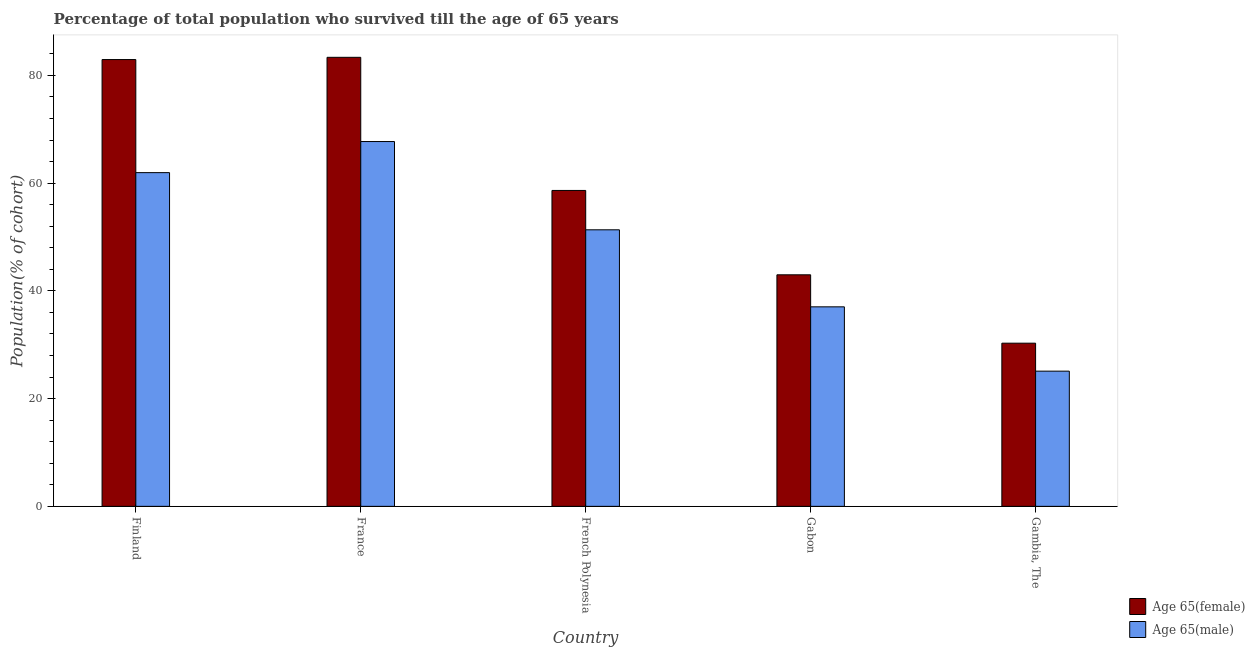How many different coloured bars are there?
Your answer should be very brief. 2. How many groups of bars are there?
Offer a terse response. 5. Are the number of bars per tick equal to the number of legend labels?
Your response must be concise. Yes. Are the number of bars on each tick of the X-axis equal?
Offer a terse response. Yes. How many bars are there on the 3rd tick from the left?
Your answer should be very brief. 2. What is the label of the 4th group of bars from the left?
Make the answer very short. Gabon. In how many cases, is the number of bars for a given country not equal to the number of legend labels?
Provide a succinct answer. 0. What is the percentage of female population who survived till age of 65 in Gabon?
Ensure brevity in your answer.  42.98. Across all countries, what is the maximum percentage of male population who survived till age of 65?
Offer a very short reply. 67.72. Across all countries, what is the minimum percentage of male population who survived till age of 65?
Provide a succinct answer. 25.1. In which country was the percentage of male population who survived till age of 65 maximum?
Offer a very short reply. France. In which country was the percentage of male population who survived till age of 65 minimum?
Provide a short and direct response. Gambia, The. What is the total percentage of male population who survived till age of 65 in the graph?
Your answer should be compact. 243.12. What is the difference between the percentage of male population who survived till age of 65 in Finland and that in France?
Provide a short and direct response. -5.77. What is the difference between the percentage of male population who survived till age of 65 in Gambia, The and the percentage of female population who survived till age of 65 in France?
Make the answer very short. -58.25. What is the average percentage of female population who survived till age of 65 per country?
Your answer should be compact. 59.64. What is the difference between the percentage of female population who survived till age of 65 and percentage of male population who survived till age of 65 in Gabon?
Offer a very short reply. 5.95. In how many countries, is the percentage of female population who survived till age of 65 greater than 52 %?
Make the answer very short. 3. What is the ratio of the percentage of female population who survived till age of 65 in Gabon to that in Gambia, The?
Your answer should be very brief. 1.42. Is the percentage of male population who survived till age of 65 in France less than that in Gambia, The?
Offer a very short reply. No. Is the difference between the percentage of female population who survived till age of 65 in French Polynesia and Gabon greater than the difference between the percentage of male population who survived till age of 65 in French Polynesia and Gabon?
Ensure brevity in your answer.  Yes. What is the difference between the highest and the second highest percentage of male population who survived till age of 65?
Provide a short and direct response. 5.77. What is the difference between the highest and the lowest percentage of female population who survived till age of 65?
Provide a short and direct response. 53.06. Is the sum of the percentage of male population who survived till age of 65 in French Polynesia and Gambia, The greater than the maximum percentage of female population who survived till age of 65 across all countries?
Give a very brief answer. No. What does the 1st bar from the left in Gambia, The represents?
Your answer should be compact. Age 65(female). What does the 2nd bar from the right in Gambia, The represents?
Provide a short and direct response. Age 65(female). Are all the bars in the graph horizontal?
Your response must be concise. No. How many countries are there in the graph?
Provide a succinct answer. 5. What is the difference between two consecutive major ticks on the Y-axis?
Provide a short and direct response. 20. Does the graph contain any zero values?
Offer a very short reply. No. Does the graph contain grids?
Offer a terse response. No. What is the title of the graph?
Offer a terse response. Percentage of total population who survived till the age of 65 years. What is the label or title of the Y-axis?
Ensure brevity in your answer.  Population(% of cohort). What is the Population(% of cohort) in Age 65(female) in Finland?
Keep it short and to the point. 82.93. What is the Population(% of cohort) in Age 65(male) in Finland?
Ensure brevity in your answer.  61.94. What is the Population(% of cohort) of Age 65(female) in France?
Your response must be concise. 83.35. What is the Population(% of cohort) of Age 65(male) in France?
Your answer should be compact. 67.72. What is the Population(% of cohort) in Age 65(female) in French Polynesia?
Make the answer very short. 58.64. What is the Population(% of cohort) of Age 65(male) in French Polynesia?
Keep it short and to the point. 51.33. What is the Population(% of cohort) of Age 65(female) in Gabon?
Your response must be concise. 42.98. What is the Population(% of cohort) in Age 65(male) in Gabon?
Your response must be concise. 37.03. What is the Population(% of cohort) in Age 65(female) in Gambia, The?
Your response must be concise. 30.29. What is the Population(% of cohort) in Age 65(male) in Gambia, The?
Offer a very short reply. 25.1. Across all countries, what is the maximum Population(% of cohort) of Age 65(female)?
Your answer should be very brief. 83.35. Across all countries, what is the maximum Population(% of cohort) in Age 65(male)?
Your response must be concise. 67.72. Across all countries, what is the minimum Population(% of cohort) in Age 65(female)?
Give a very brief answer. 30.29. Across all countries, what is the minimum Population(% of cohort) in Age 65(male)?
Offer a terse response. 25.1. What is the total Population(% of cohort) in Age 65(female) in the graph?
Give a very brief answer. 298.18. What is the total Population(% of cohort) in Age 65(male) in the graph?
Offer a very short reply. 243.12. What is the difference between the Population(% of cohort) in Age 65(female) in Finland and that in France?
Your answer should be compact. -0.41. What is the difference between the Population(% of cohort) of Age 65(male) in Finland and that in France?
Make the answer very short. -5.77. What is the difference between the Population(% of cohort) of Age 65(female) in Finland and that in French Polynesia?
Give a very brief answer. 24.3. What is the difference between the Population(% of cohort) in Age 65(male) in Finland and that in French Polynesia?
Offer a very short reply. 10.61. What is the difference between the Population(% of cohort) in Age 65(female) in Finland and that in Gabon?
Keep it short and to the point. 39.95. What is the difference between the Population(% of cohort) of Age 65(male) in Finland and that in Gabon?
Keep it short and to the point. 24.91. What is the difference between the Population(% of cohort) of Age 65(female) in Finland and that in Gambia, The?
Give a very brief answer. 52.65. What is the difference between the Population(% of cohort) in Age 65(male) in Finland and that in Gambia, The?
Offer a very short reply. 36.85. What is the difference between the Population(% of cohort) in Age 65(female) in France and that in French Polynesia?
Your response must be concise. 24.71. What is the difference between the Population(% of cohort) in Age 65(male) in France and that in French Polynesia?
Keep it short and to the point. 16.38. What is the difference between the Population(% of cohort) in Age 65(female) in France and that in Gabon?
Ensure brevity in your answer.  40.37. What is the difference between the Population(% of cohort) in Age 65(male) in France and that in Gabon?
Provide a short and direct response. 30.68. What is the difference between the Population(% of cohort) of Age 65(female) in France and that in Gambia, The?
Provide a short and direct response. 53.06. What is the difference between the Population(% of cohort) in Age 65(male) in France and that in Gambia, The?
Provide a succinct answer. 42.62. What is the difference between the Population(% of cohort) in Age 65(female) in French Polynesia and that in Gabon?
Provide a succinct answer. 15.66. What is the difference between the Population(% of cohort) of Age 65(male) in French Polynesia and that in Gabon?
Your response must be concise. 14.3. What is the difference between the Population(% of cohort) in Age 65(female) in French Polynesia and that in Gambia, The?
Keep it short and to the point. 28.35. What is the difference between the Population(% of cohort) of Age 65(male) in French Polynesia and that in Gambia, The?
Ensure brevity in your answer.  26.24. What is the difference between the Population(% of cohort) of Age 65(female) in Gabon and that in Gambia, The?
Ensure brevity in your answer.  12.69. What is the difference between the Population(% of cohort) of Age 65(male) in Gabon and that in Gambia, The?
Keep it short and to the point. 11.94. What is the difference between the Population(% of cohort) in Age 65(female) in Finland and the Population(% of cohort) in Age 65(male) in France?
Offer a very short reply. 15.22. What is the difference between the Population(% of cohort) in Age 65(female) in Finland and the Population(% of cohort) in Age 65(male) in French Polynesia?
Provide a succinct answer. 31.6. What is the difference between the Population(% of cohort) in Age 65(female) in Finland and the Population(% of cohort) in Age 65(male) in Gabon?
Your answer should be very brief. 45.9. What is the difference between the Population(% of cohort) of Age 65(female) in Finland and the Population(% of cohort) of Age 65(male) in Gambia, The?
Your answer should be compact. 57.84. What is the difference between the Population(% of cohort) of Age 65(female) in France and the Population(% of cohort) of Age 65(male) in French Polynesia?
Make the answer very short. 32.02. What is the difference between the Population(% of cohort) of Age 65(female) in France and the Population(% of cohort) of Age 65(male) in Gabon?
Your answer should be compact. 46.31. What is the difference between the Population(% of cohort) in Age 65(female) in France and the Population(% of cohort) in Age 65(male) in Gambia, The?
Offer a very short reply. 58.25. What is the difference between the Population(% of cohort) of Age 65(female) in French Polynesia and the Population(% of cohort) of Age 65(male) in Gabon?
Your answer should be very brief. 21.6. What is the difference between the Population(% of cohort) of Age 65(female) in French Polynesia and the Population(% of cohort) of Age 65(male) in Gambia, The?
Your answer should be compact. 33.54. What is the difference between the Population(% of cohort) in Age 65(female) in Gabon and the Population(% of cohort) in Age 65(male) in Gambia, The?
Keep it short and to the point. 17.88. What is the average Population(% of cohort) in Age 65(female) per country?
Ensure brevity in your answer.  59.64. What is the average Population(% of cohort) in Age 65(male) per country?
Keep it short and to the point. 48.62. What is the difference between the Population(% of cohort) of Age 65(female) and Population(% of cohort) of Age 65(male) in Finland?
Your answer should be compact. 20.99. What is the difference between the Population(% of cohort) in Age 65(female) and Population(% of cohort) in Age 65(male) in France?
Your answer should be very brief. 15.63. What is the difference between the Population(% of cohort) in Age 65(female) and Population(% of cohort) in Age 65(male) in French Polynesia?
Your answer should be compact. 7.3. What is the difference between the Population(% of cohort) in Age 65(female) and Population(% of cohort) in Age 65(male) in Gabon?
Ensure brevity in your answer.  5.95. What is the difference between the Population(% of cohort) of Age 65(female) and Population(% of cohort) of Age 65(male) in Gambia, The?
Your answer should be compact. 5.19. What is the ratio of the Population(% of cohort) in Age 65(male) in Finland to that in France?
Ensure brevity in your answer.  0.91. What is the ratio of the Population(% of cohort) in Age 65(female) in Finland to that in French Polynesia?
Your answer should be compact. 1.41. What is the ratio of the Population(% of cohort) of Age 65(male) in Finland to that in French Polynesia?
Offer a terse response. 1.21. What is the ratio of the Population(% of cohort) in Age 65(female) in Finland to that in Gabon?
Your response must be concise. 1.93. What is the ratio of the Population(% of cohort) in Age 65(male) in Finland to that in Gabon?
Offer a very short reply. 1.67. What is the ratio of the Population(% of cohort) in Age 65(female) in Finland to that in Gambia, The?
Offer a terse response. 2.74. What is the ratio of the Population(% of cohort) in Age 65(male) in Finland to that in Gambia, The?
Ensure brevity in your answer.  2.47. What is the ratio of the Population(% of cohort) of Age 65(female) in France to that in French Polynesia?
Give a very brief answer. 1.42. What is the ratio of the Population(% of cohort) of Age 65(male) in France to that in French Polynesia?
Offer a very short reply. 1.32. What is the ratio of the Population(% of cohort) in Age 65(female) in France to that in Gabon?
Provide a short and direct response. 1.94. What is the ratio of the Population(% of cohort) in Age 65(male) in France to that in Gabon?
Your answer should be compact. 1.83. What is the ratio of the Population(% of cohort) of Age 65(female) in France to that in Gambia, The?
Provide a succinct answer. 2.75. What is the ratio of the Population(% of cohort) in Age 65(male) in France to that in Gambia, The?
Your answer should be compact. 2.7. What is the ratio of the Population(% of cohort) in Age 65(female) in French Polynesia to that in Gabon?
Your response must be concise. 1.36. What is the ratio of the Population(% of cohort) in Age 65(male) in French Polynesia to that in Gabon?
Keep it short and to the point. 1.39. What is the ratio of the Population(% of cohort) of Age 65(female) in French Polynesia to that in Gambia, The?
Ensure brevity in your answer.  1.94. What is the ratio of the Population(% of cohort) in Age 65(male) in French Polynesia to that in Gambia, The?
Provide a succinct answer. 2.05. What is the ratio of the Population(% of cohort) in Age 65(female) in Gabon to that in Gambia, The?
Your response must be concise. 1.42. What is the ratio of the Population(% of cohort) in Age 65(male) in Gabon to that in Gambia, The?
Ensure brevity in your answer.  1.48. What is the difference between the highest and the second highest Population(% of cohort) of Age 65(female)?
Provide a succinct answer. 0.41. What is the difference between the highest and the second highest Population(% of cohort) of Age 65(male)?
Provide a short and direct response. 5.77. What is the difference between the highest and the lowest Population(% of cohort) of Age 65(female)?
Ensure brevity in your answer.  53.06. What is the difference between the highest and the lowest Population(% of cohort) in Age 65(male)?
Offer a terse response. 42.62. 